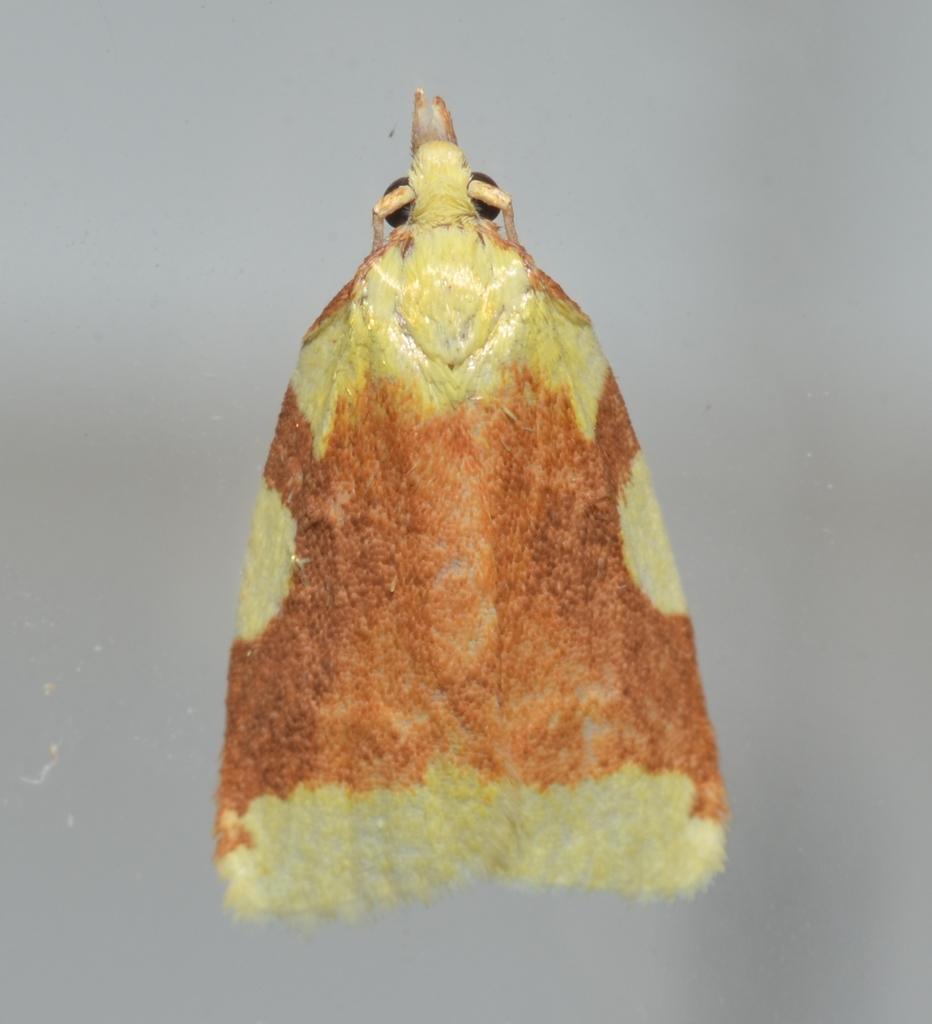Please provide a concise description of this image. In the middle of the image there is a moth. It is orange and yellow in colors. In this image the background is gray in color. 